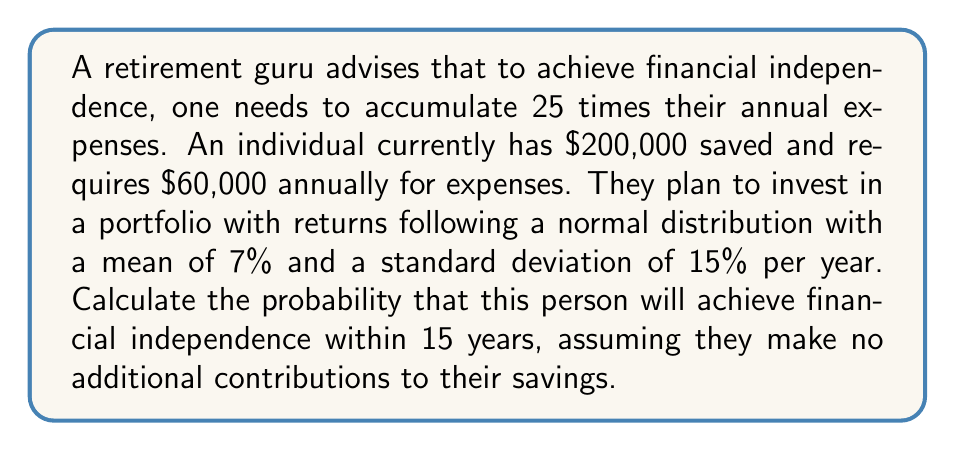Teach me how to tackle this problem. Let's approach this step-by-step:

1) First, we need to calculate the target amount for financial independence:
   $25 \times $60,000 = $1,500,000

2) We need to determine how much the initial $200,000 needs to grow to reach $1,500,000:
   Growth factor = $1,500,000 / $200,000 = 7.5

3) Using the compound interest formula, we can set up the equation:
   $7.5 = (1 + r)^{15}$, where r is the required annual return

4) Solving for r:
   $r = 7.5^{1/15} - 1 \approx 0.1372$ or 13.72% per year

5) We know that the actual returns follow a normal distribution with:
   $\mu = 7\%$ and $\sigma = 15\%$ per year

6) To find the probability, we need to calculate the z-score:
   $z = \frac{x - \mu}{\sigma} = \frac{0.1372 - 0.07}{0.15} \approx 0.4480$

7) Using a standard normal distribution table or calculator, we can find the probability:
   $P(Z > 0.4480) = 1 - P(Z < 0.4480) \approx 1 - 0.6729 = 0.3271$

Therefore, the probability of achieving financial independence within 15 years is approximately 0.3271 or 32.71%.
Answer: $0.3271$ or $32.71\%$ 